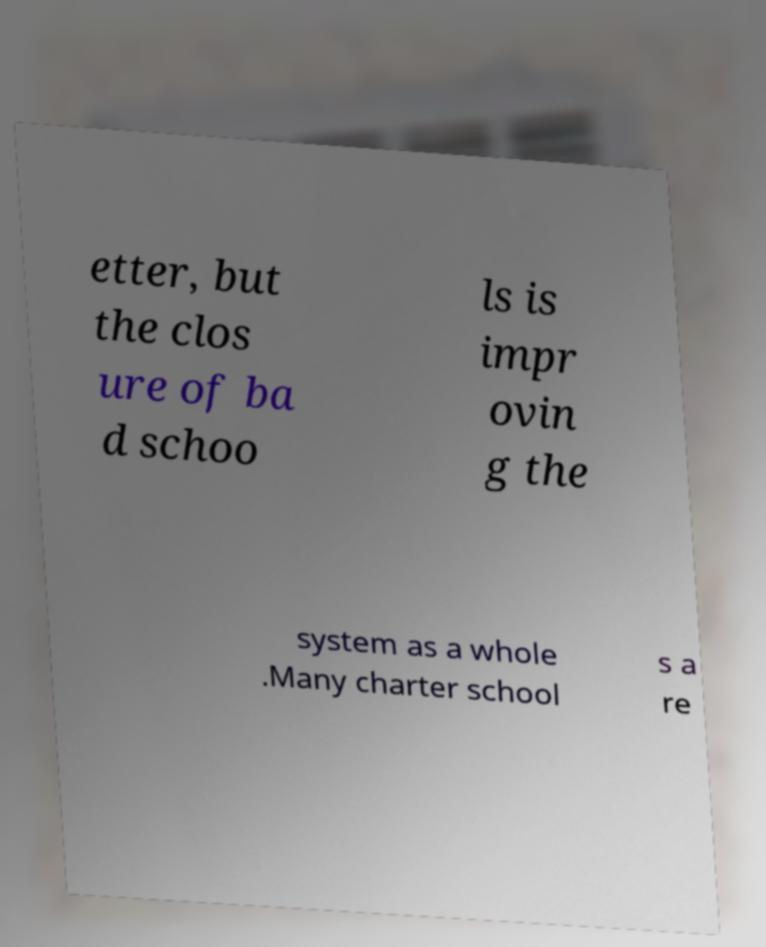Can you accurately transcribe the text from the provided image for me? etter, but the clos ure of ba d schoo ls is impr ovin g the system as a whole .Many charter school s a re 